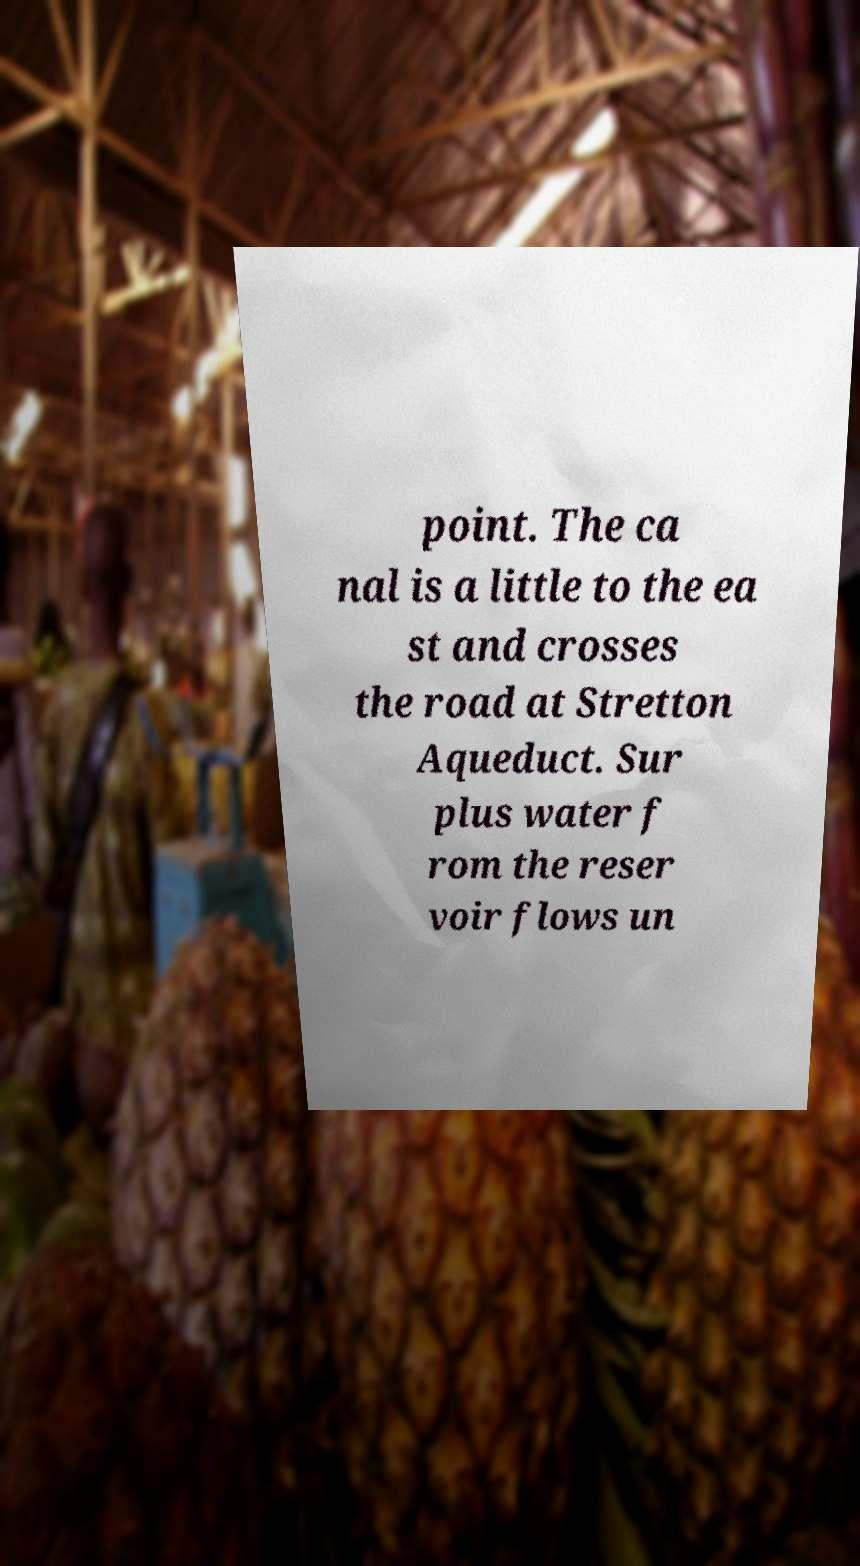Can you read and provide the text displayed in the image?This photo seems to have some interesting text. Can you extract and type it out for me? point. The ca nal is a little to the ea st and crosses the road at Stretton Aqueduct. Sur plus water f rom the reser voir flows un 